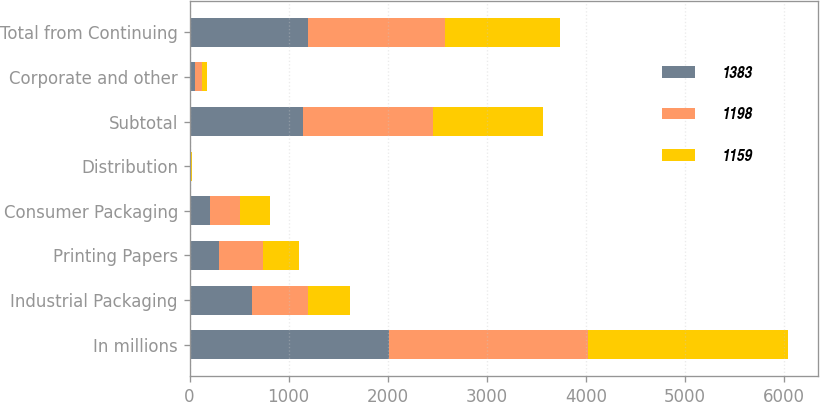Convert chart to OTSL. <chart><loc_0><loc_0><loc_500><loc_500><stacked_bar_chart><ecel><fcel>In millions<fcel>Industrial Packaging<fcel>Printing Papers<fcel>Consumer Packaging<fcel>Distribution<fcel>Subtotal<fcel>Corporate and other<fcel>Total from Continuing<nl><fcel>1383<fcel>2013<fcel>629<fcel>294<fcel>208<fcel>9<fcel>1140<fcel>58<fcel>1198<nl><fcel>1198<fcel>2012<fcel>565<fcel>449<fcel>296<fcel>10<fcel>1320<fcel>63<fcel>1383<nl><fcel>1159<fcel>2011<fcel>426<fcel>364<fcel>310<fcel>8<fcel>1108<fcel>51<fcel>1159<nl></chart> 